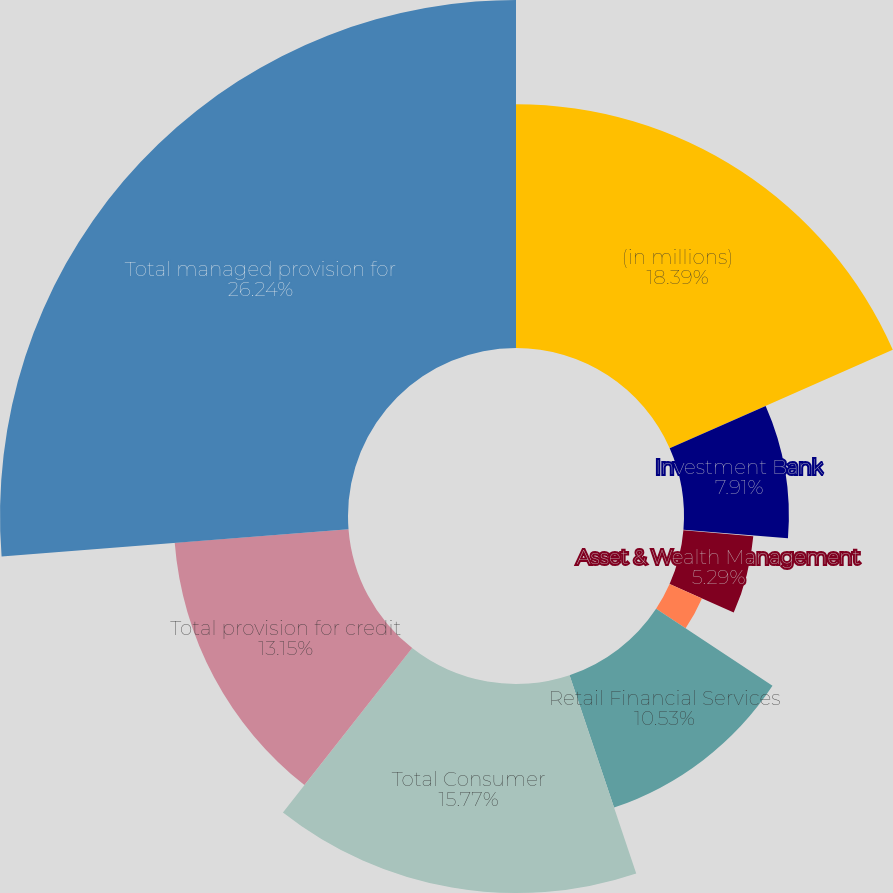Convert chart. <chart><loc_0><loc_0><loc_500><loc_500><pie_chart><fcel>(in millions)<fcel>Investment Bank<fcel>Commercial Banking<fcel>Asset & Wealth Management<fcel>Total Wholesale<fcel>Retail Financial Services<fcel>Total Consumer<fcel>Total provision for credit<fcel>Total managed provision for<nl><fcel>18.39%<fcel>7.91%<fcel>0.05%<fcel>5.29%<fcel>2.67%<fcel>10.53%<fcel>15.77%<fcel>13.15%<fcel>26.25%<nl></chart> 